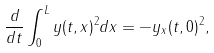Convert formula to latex. <formula><loc_0><loc_0><loc_500><loc_500>\frac { d } { d t } \int _ { 0 } ^ { L } y ( t , x ) ^ { 2 } d x = - y _ { x } ( t , 0 ) ^ { 2 } ,</formula> 